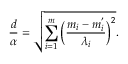Convert formula to latex. <formula><loc_0><loc_0><loc_500><loc_500>\frac { d } { \alpha } = \sqrt { \sum _ { i = 1 } ^ { m } \left ( \frac { m _ { i } - m _ { i } ^ { ^ { \prime } } } { \lambda _ { i } } \right ) ^ { 2 } } .</formula> 